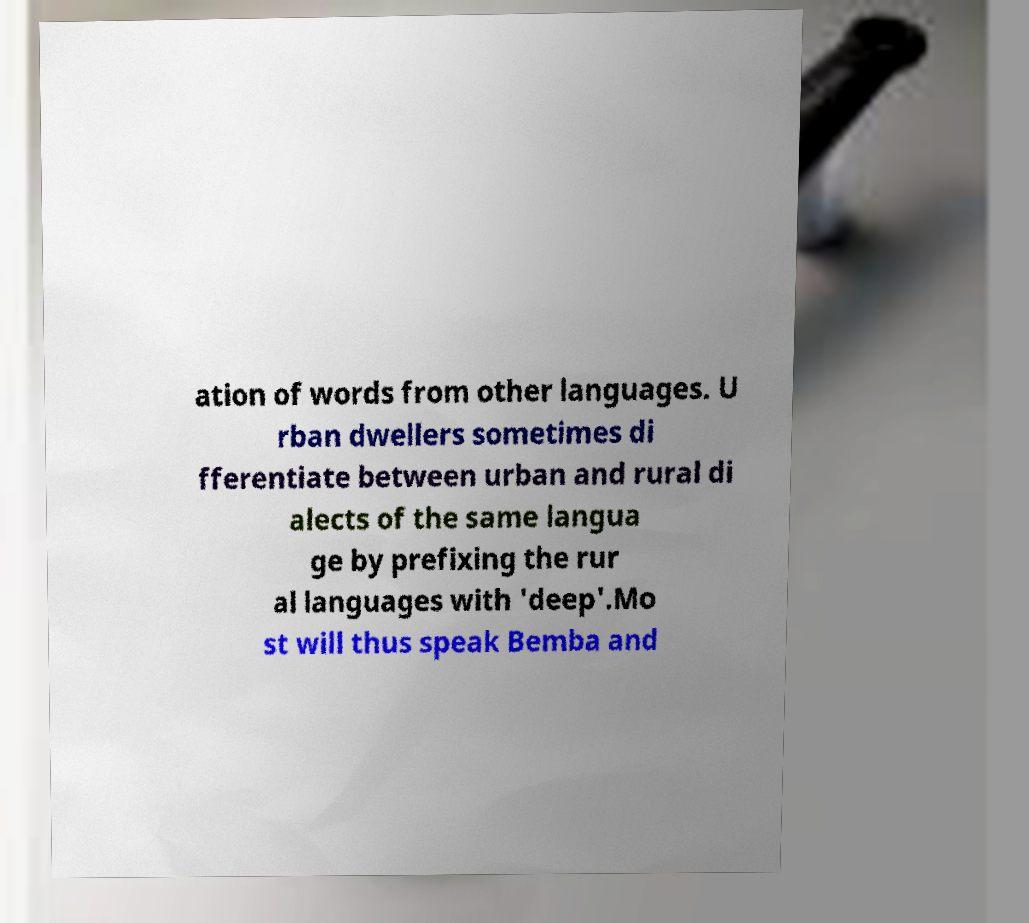Can you accurately transcribe the text from the provided image for me? ation of words from other languages. U rban dwellers sometimes di fferentiate between urban and rural di alects of the same langua ge by prefixing the rur al languages with 'deep'.Mo st will thus speak Bemba and 